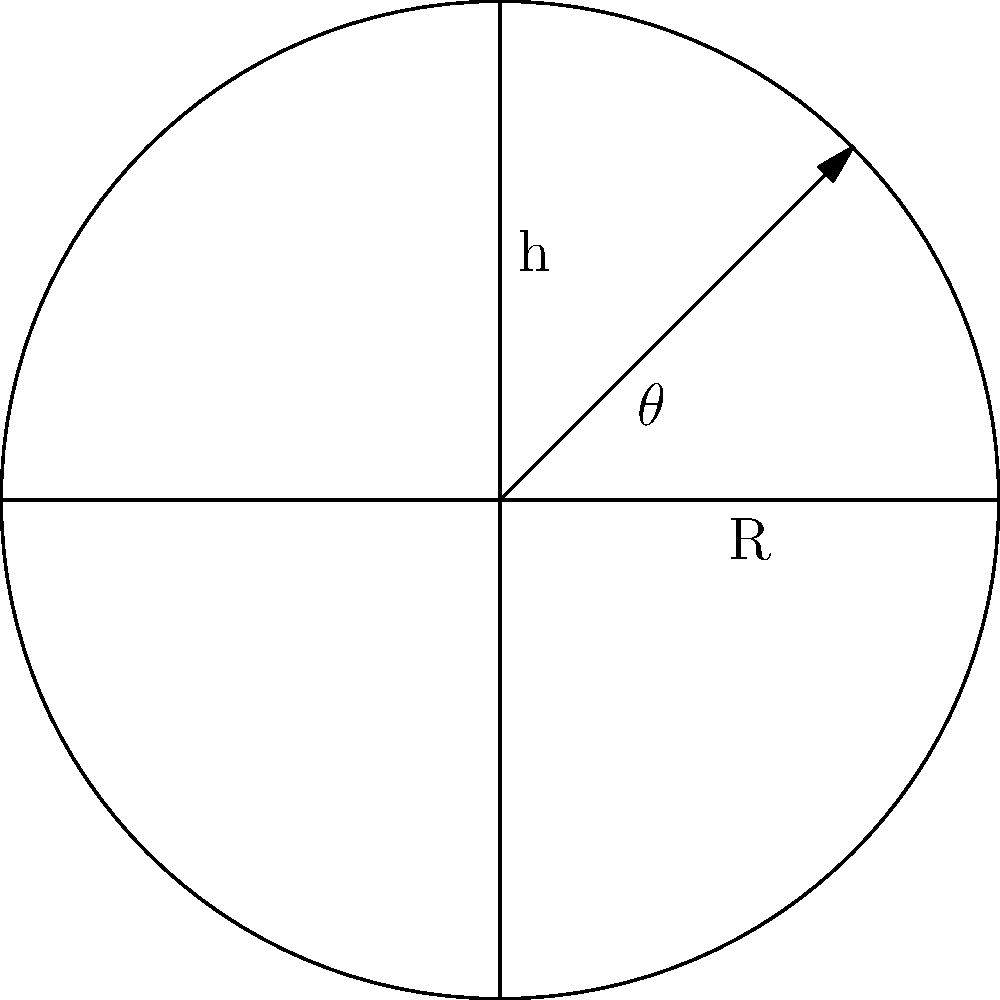In the design of a dome-shaped mosque roof, how does the height (h) of the dome relate to its radius (R) and the angle ($\theta$) from the base to the peak? Can you explain why this relationship is important for the structural integrity of the dome? To understand the relationship between the height (h), radius (R), and angle ($\theta$) of a dome, let's follow these steps:

1. In a circular dome, we can see that these elements form a right-angled triangle.

2. The relationship between h, R, and $\theta$ can be expressed using trigonometry:

   $\tan(\theta) = \frac{h}{R}$

3. This can be rearranged to:

   $h = R \tan(\theta)$

4. This relationship is crucial for the structural integrity of the dome because:

   a) It determines the dome's shape, which affects how forces are distributed.
   
   b) A higher dome (larger h) for a given radius will have a steeper angle, potentially increasing lateral forces.
   
   c) A lower dome might not provide enough height for proper interior space.

5. The optimal ratio of h to R is often considered to be around 0.5, which corresponds to an angle of about 30 degrees. This provides a good balance between:

   a) Structural stability
   b) Aesthetic appeal
   c) Interior space efficiency

6. Understanding this relationship allows engineers to:

   a) Design domes that can effectively transfer loads to the supporting structure
   b) Minimize material use while maintaining strength
   c) Create visually pleasing and functionally effective mosque roofs

By carefully considering the h/R ratio and the resulting angle, engineers can ensure that the dome is both beautiful and structurally sound, fulfilling both the spiritual and practical needs of the mosque.
Answer: $h = R \tan(\theta)$; crucial for force distribution, stability, and space efficiency 